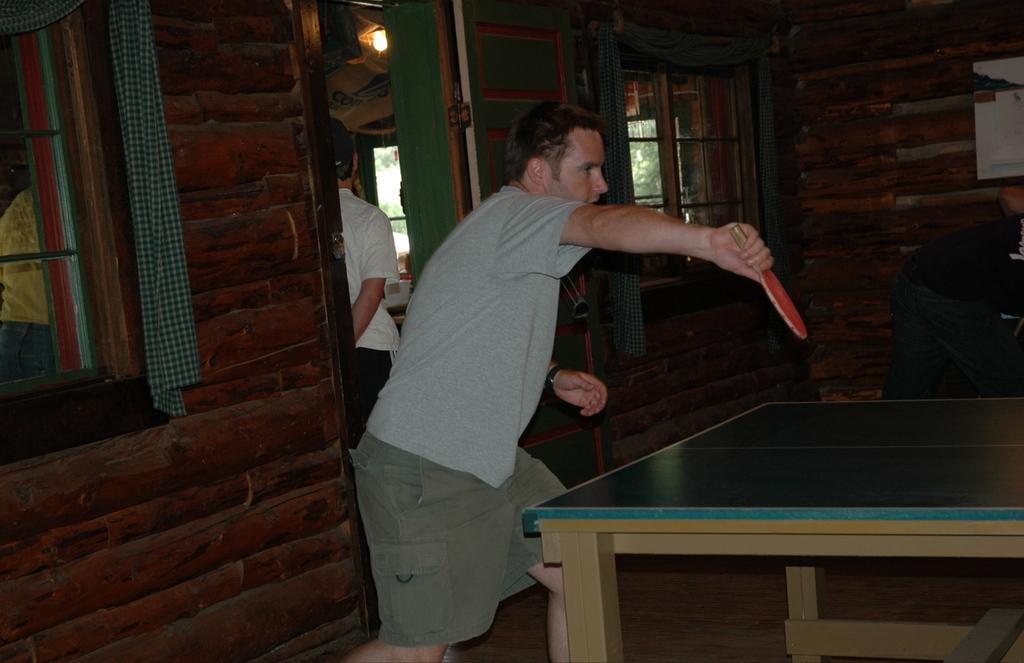Can you describe this image briefly? In this pictures i could see a person playing table tennis holding a bat in his right hand. In the back ground i could see the other person standing and there are some brick walls which is red in color and curtains. 